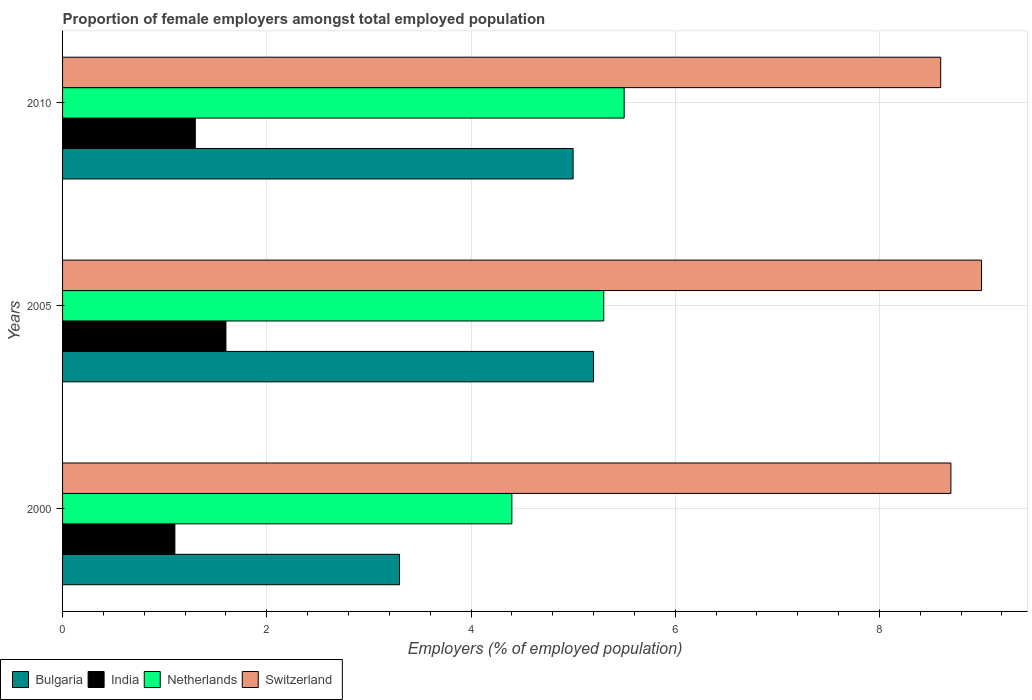Are the number of bars on each tick of the Y-axis equal?
Provide a short and direct response. Yes. How many bars are there on the 1st tick from the top?
Ensure brevity in your answer.  4. What is the label of the 2nd group of bars from the top?
Provide a short and direct response. 2005. In how many cases, is the number of bars for a given year not equal to the number of legend labels?
Give a very brief answer. 0. What is the proportion of female employers in India in 2005?
Your response must be concise. 1.6. Across all years, what is the maximum proportion of female employers in India?
Offer a terse response. 1.6. Across all years, what is the minimum proportion of female employers in India?
Offer a terse response. 1.1. In which year was the proportion of female employers in India minimum?
Give a very brief answer. 2000. What is the total proportion of female employers in Switzerland in the graph?
Offer a very short reply. 26.3. What is the difference between the proportion of female employers in Netherlands in 2000 and that in 2010?
Provide a short and direct response. -1.1. What is the difference between the proportion of female employers in Bulgaria in 2010 and the proportion of female employers in India in 2000?
Provide a short and direct response. 3.9. What is the average proportion of female employers in Switzerland per year?
Give a very brief answer. 8.77. In the year 2000, what is the difference between the proportion of female employers in Netherlands and proportion of female employers in Switzerland?
Give a very brief answer. -4.3. What is the ratio of the proportion of female employers in Bulgaria in 2005 to that in 2010?
Your answer should be compact. 1.04. What is the difference between the highest and the second highest proportion of female employers in Netherlands?
Provide a short and direct response. 0.2. What is the difference between the highest and the lowest proportion of female employers in Netherlands?
Keep it short and to the point. 1.1. Are all the bars in the graph horizontal?
Give a very brief answer. Yes. Are the values on the major ticks of X-axis written in scientific E-notation?
Your answer should be compact. No. Where does the legend appear in the graph?
Offer a terse response. Bottom left. How many legend labels are there?
Your response must be concise. 4. What is the title of the graph?
Ensure brevity in your answer.  Proportion of female employers amongst total employed population. Does "South Sudan" appear as one of the legend labels in the graph?
Offer a very short reply. No. What is the label or title of the X-axis?
Ensure brevity in your answer.  Employers (% of employed population). What is the label or title of the Y-axis?
Provide a succinct answer. Years. What is the Employers (% of employed population) in Bulgaria in 2000?
Provide a succinct answer. 3.3. What is the Employers (% of employed population) in India in 2000?
Offer a very short reply. 1.1. What is the Employers (% of employed population) in Netherlands in 2000?
Keep it short and to the point. 4.4. What is the Employers (% of employed population) of Switzerland in 2000?
Offer a terse response. 8.7. What is the Employers (% of employed population) of Bulgaria in 2005?
Your answer should be very brief. 5.2. What is the Employers (% of employed population) of India in 2005?
Offer a terse response. 1.6. What is the Employers (% of employed population) of Netherlands in 2005?
Keep it short and to the point. 5.3. What is the Employers (% of employed population) of Bulgaria in 2010?
Your answer should be compact. 5. What is the Employers (% of employed population) in India in 2010?
Your answer should be very brief. 1.3. What is the Employers (% of employed population) of Switzerland in 2010?
Keep it short and to the point. 8.6. Across all years, what is the maximum Employers (% of employed population) in Bulgaria?
Your answer should be very brief. 5.2. Across all years, what is the maximum Employers (% of employed population) of India?
Provide a short and direct response. 1.6. Across all years, what is the minimum Employers (% of employed population) in Bulgaria?
Your answer should be very brief. 3.3. Across all years, what is the minimum Employers (% of employed population) in India?
Ensure brevity in your answer.  1.1. Across all years, what is the minimum Employers (% of employed population) of Netherlands?
Ensure brevity in your answer.  4.4. Across all years, what is the minimum Employers (% of employed population) of Switzerland?
Your answer should be compact. 8.6. What is the total Employers (% of employed population) in Bulgaria in the graph?
Make the answer very short. 13.5. What is the total Employers (% of employed population) in India in the graph?
Give a very brief answer. 4. What is the total Employers (% of employed population) of Netherlands in the graph?
Keep it short and to the point. 15.2. What is the total Employers (% of employed population) of Switzerland in the graph?
Offer a terse response. 26.3. What is the difference between the Employers (% of employed population) in India in 2000 and that in 2005?
Your answer should be very brief. -0.5. What is the difference between the Employers (% of employed population) of Bulgaria in 2000 and that in 2010?
Offer a terse response. -1.7. What is the difference between the Employers (% of employed population) in India in 2000 and that in 2010?
Provide a short and direct response. -0.2. What is the difference between the Employers (% of employed population) in Switzerland in 2000 and that in 2010?
Ensure brevity in your answer.  0.1. What is the difference between the Employers (% of employed population) in India in 2005 and that in 2010?
Provide a succinct answer. 0.3. What is the difference between the Employers (% of employed population) in India in 2000 and the Employers (% of employed population) in Netherlands in 2005?
Ensure brevity in your answer.  -4.2. What is the difference between the Employers (% of employed population) of Bulgaria in 2000 and the Employers (% of employed population) of India in 2010?
Your answer should be compact. 2. What is the difference between the Employers (% of employed population) in Bulgaria in 2000 and the Employers (% of employed population) in Netherlands in 2010?
Make the answer very short. -2.2. What is the difference between the Employers (% of employed population) of India in 2000 and the Employers (% of employed population) of Netherlands in 2010?
Keep it short and to the point. -4.4. What is the difference between the Employers (% of employed population) of India in 2000 and the Employers (% of employed population) of Switzerland in 2010?
Give a very brief answer. -7.5. What is the difference between the Employers (% of employed population) in Netherlands in 2000 and the Employers (% of employed population) in Switzerland in 2010?
Your answer should be compact. -4.2. What is the difference between the Employers (% of employed population) of Bulgaria in 2005 and the Employers (% of employed population) of Switzerland in 2010?
Make the answer very short. -3.4. What is the difference between the Employers (% of employed population) in India in 2005 and the Employers (% of employed population) in Netherlands in 2010?
Make the answer very short. -3.9. What is the difference between the Employers (% of employed population) in Netherlands in 2005 and the Employers (% of employed population) in Switzerland in 2010?
Offer a terse response. -3.3. What is the average Employers (% of employed population) in Bulgaria per year?
Make the answer very short. 4.5. What is the average Employers (% of employed population) of India per year?
Give a very brief answer. 1.33. What is the average Employers (% of employed population) in Netherlands per year?
Give a very brief answer. 5.07. What is the average Employers (% of employed population) in Switzerland per year?
Give a very brief answer. 8.77. In the year 2000, what is the difference between the Employers (% of employed population) in Bulgaria and Employers (% of employed population) in India?
Your response must be concise. 2.2. In the year 2000, what is the difference between the Employers (% of employed population) of Bulgaria and Employers (% of employed population) of Switzerland?
Your answer should be compact. -5.4. In the year 2000, what is the difference between the Employers (% of employed population) of India and Employers (% of employed population) of Netherlands?
Offer a very short reply. -3.3. In the year 2005, what is the difference between the Employers (% of employed population) in Bulgaria and Employers (% of employed population) in India?
Offer a very short reply. 3.6. In the year 2005, what is the difference between the Employers (% of employed population) in India and Employers (% of employed population) in Netherlands?
Your response must be concise. -3.7. In the year 2005, what is the difference between the Employers (% of employed population) in India and Employers (% of employed population) in Switzerland?
Offer a very short reply. -7.4. In the year 2005, what is the difference between the Employers (% of employed population) of Netherlands and Employers (% of employed population) of Switzerland?
Provide a short and direct response. -3.7. In the year 2010, what is the difference between the Employers (% of employed population) of Bulgaria and Employers (% of employed population) of India?
Make the answer very short. 3.7. In the year 2010, what is the difference between the Employers (% of employed population) of Bulgaria and Employers (% of employed population) of Netherlands?
Your answer should be very brief. -0.5. In the year 2010, what is the difference between the Employers (% of employed population) in Bulgaria and Employers (% of employed population) in Switzerland?
Offer a terse response. -3.6. In the year 2010, what is the difference between the Employers (% of employed population) of India and Employers (% of employed population) of Netherlands?
Make the answer very short. -4.2. In the year 2010, what is the difference between the Employers (% of employed population) in India and Employers (% of employed population) in Switzerland?
Your answer should be compact. -7.3. What is the ratio of the Employers (% of employed population) in Bulgaria in 2000 to that in 2005?
Keep it short and to the point. 0.63. What is the ratio of the Employers (% of employed population) of India in 2000 to that in 2005?
Make the answer very short. 0.69. What is the ratio of the Employers (% of employed population) of Netherlands in 2000 to that in 2005?
Give a very brief answer. 0.83. What is the ratio of the Employers (% of employed population) of Switzerland in 2000 to that in 2005?
Provide a short and direct response. 0.97. What is the ratio of the Employers (% of employed population) in Bulgaria in 2000 to that in 2010?
Ensure brevity in your answer.  0.66. What is the ratio of the Employers (% of employed population) of India in 2000 to that in 2010?
Make the answer very short. 0.85. What is the ratio of the Employers (% of employed population) of Netherlands in 2000 to that in 2010?
Your answer should be very brief. 0.8. What is the ratio of the Employers (% of employed population) of Switzerland in 2000 to that in 2010?
Make the answer very short. 1.01. What is the ratio of the Employers (% of employed population) of India in 2005 to that in 2010?
Your answer should be very brief. 1.23. What is the ratio of the Employers (% of employed population) of Netherlands in 2005 to that in 2010?
Provide a succinct answer. 0.96. What is the ratio of the Employers (% of employed population) of Switzerland in 2005 to that in 2010?
Offer a very short reply. 1.05. What is the difference between the highest and the second highest Employers (% of employed population) of Bulgaria?
Offer a very short reply. 0.2. What is the difference between the highest and the second highest Employers (% of employed population) of India?
Offer a terse response. 0.3. What is the difference between the highest and the second highest Employers (% of employed population) in Switzerland?
Keep it short and to the point. 0.3. What is the difference between the highest and the lowest Employers (% of employed population) of Bulgaria?
Keep it short and to the point. 1.9. What is the difference between the highest and the lowest Employers (% of employed population) of Switzerland?
Provide a short and direct response. 0.4. 